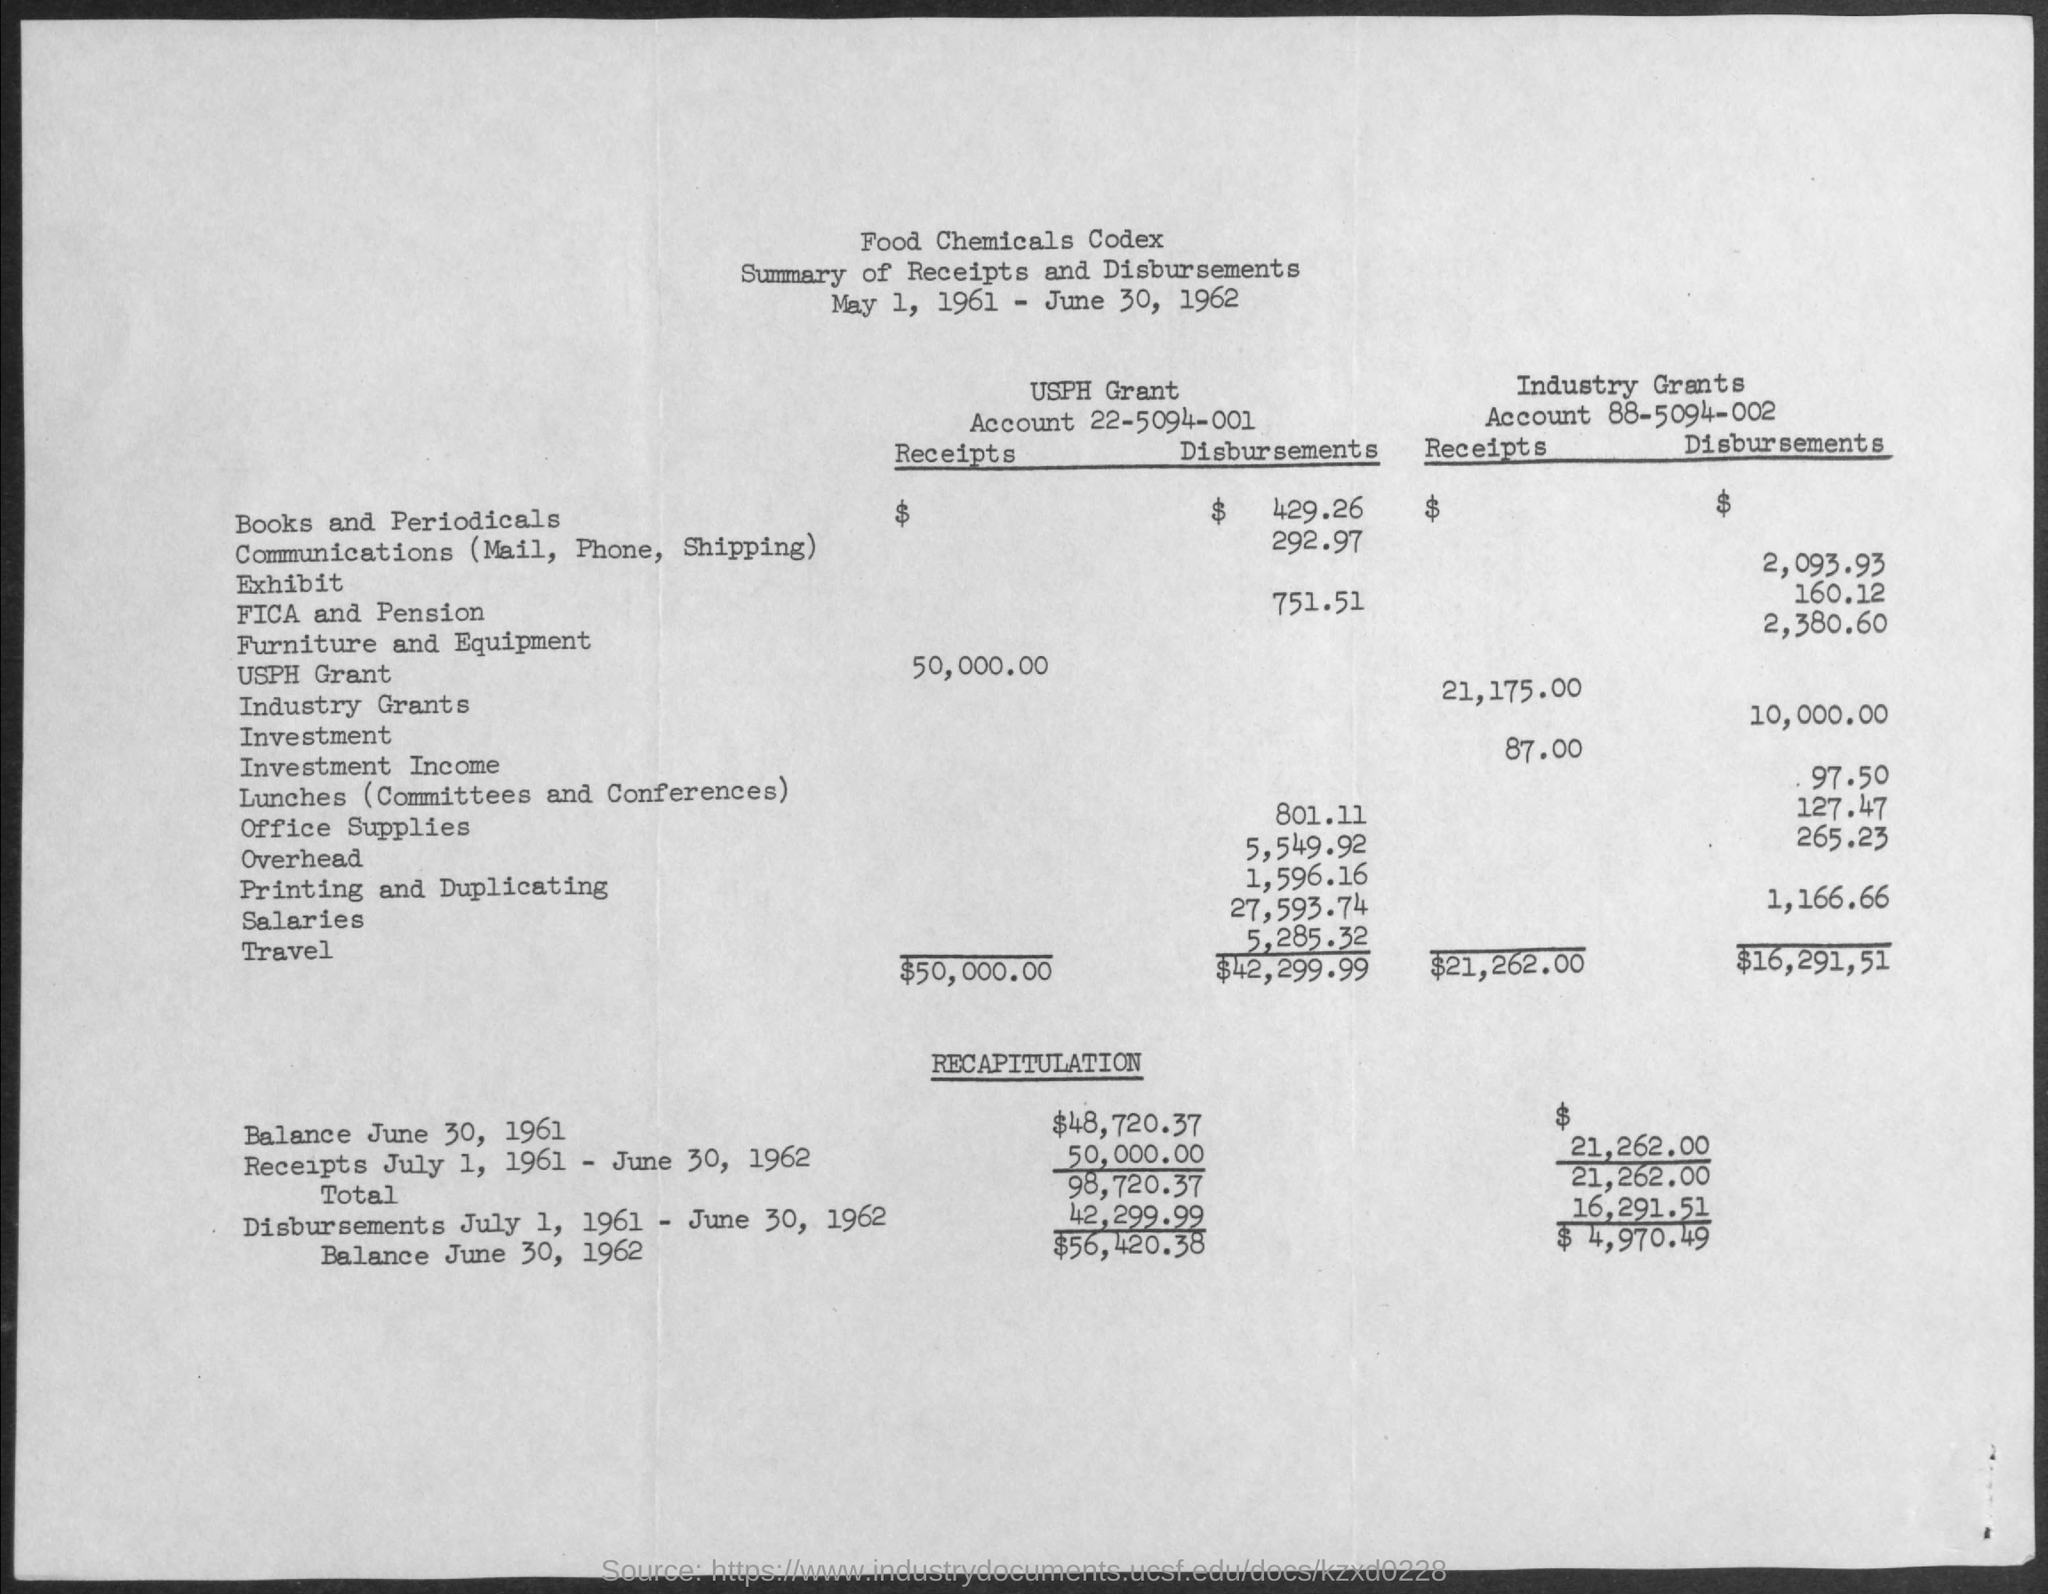Identify some key points in this picture. The document mentions that the date range for the document is from May 1, 1961 to June 30, 1962. The Industry Grants Account Number is 88-5094-002. The USPH grant account number is 22-5094-001. 